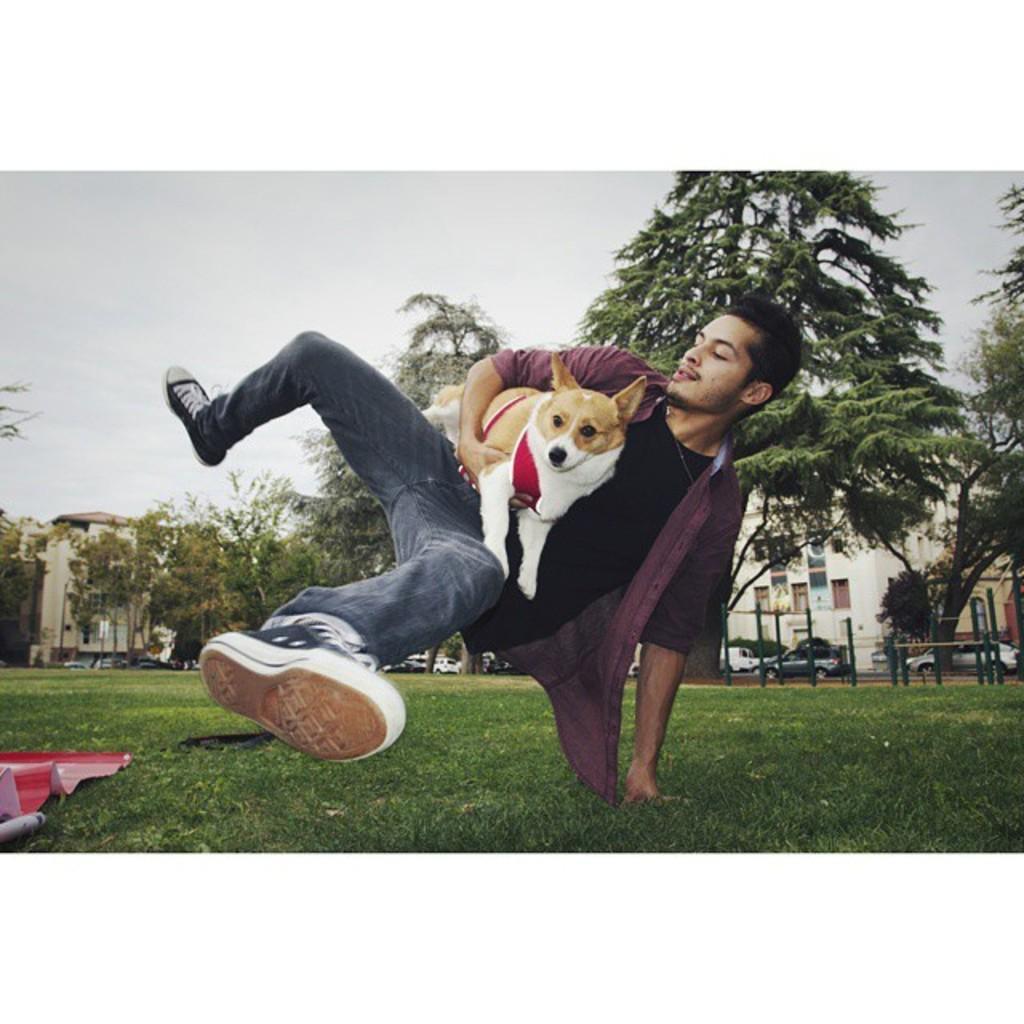In one or two sentences, can you explain what this image depicts? In this image I can see an open grass ground, a man and I can see he is holding a dog. I can see he is wearing brown colour shirt, black t shirt, jeans and shoes. I can also see an object over here and in the background I can see few buildings, few moles and number of vehicles. 